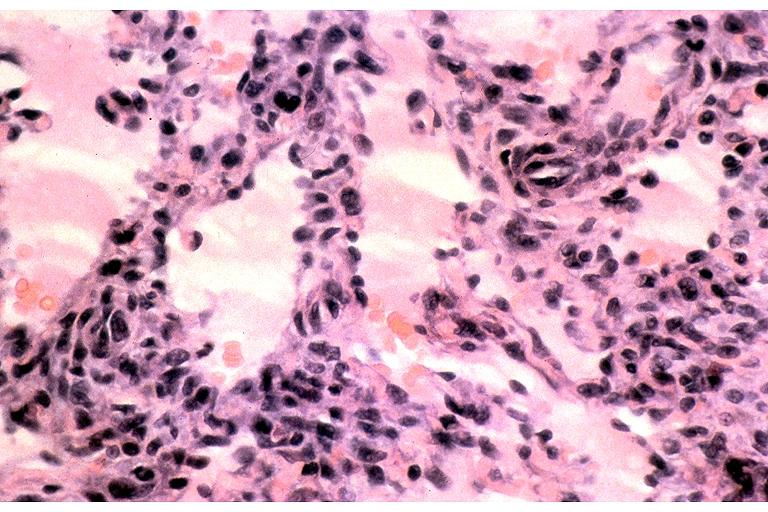does this image show kaposi sarcoma?
Answer the question using a single word or phrase. Yes 